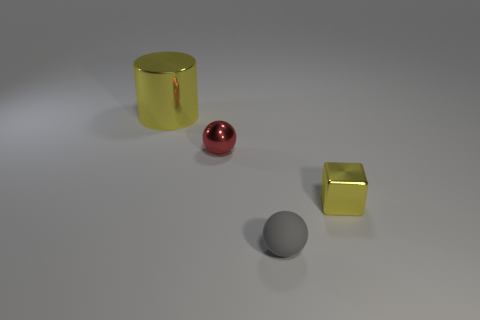Subtract all purple cylinders. Subtract all purple blocks. How many cylinders are left? 1 Add 2 large blue matte balls. How many objects exist? 6 Subtract all cylinders. How many objects are left? 3 Subtract 0 purple spheres. How many objects are left? 4 Subtract all brown rubber cylinders. Subtract all small gray matte objects. How many objects are left? 3 Add 3 yellow metal cylinders. How many yellow metal cylinders are left? 4 Add 4 blue matte objects. How many blue matte objects exist? 4 